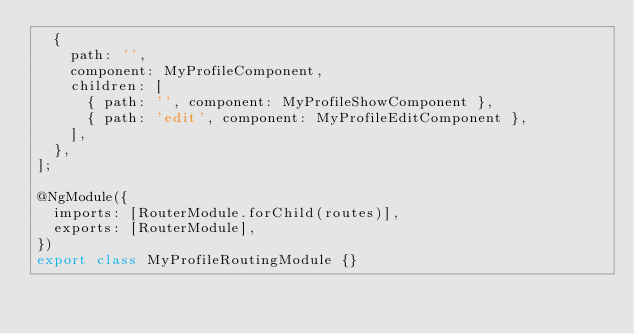Convert code to text. <code><loc_0><loc_0><loc_500><loc_500><_TypeScript_>  {
    path: '',
    component: MyProfileComponent,
    children: [
      { path: '', component: MyProfileShowComponent },
      { path: 'edit', component: MyProfileEditComponent },
    ],
  },
];

@NgModule({
  imports: [RouterModule.forChild(routes)],
  exports: [RouterModule],
})
export class MyProfileRoutingModule {}
</code> 